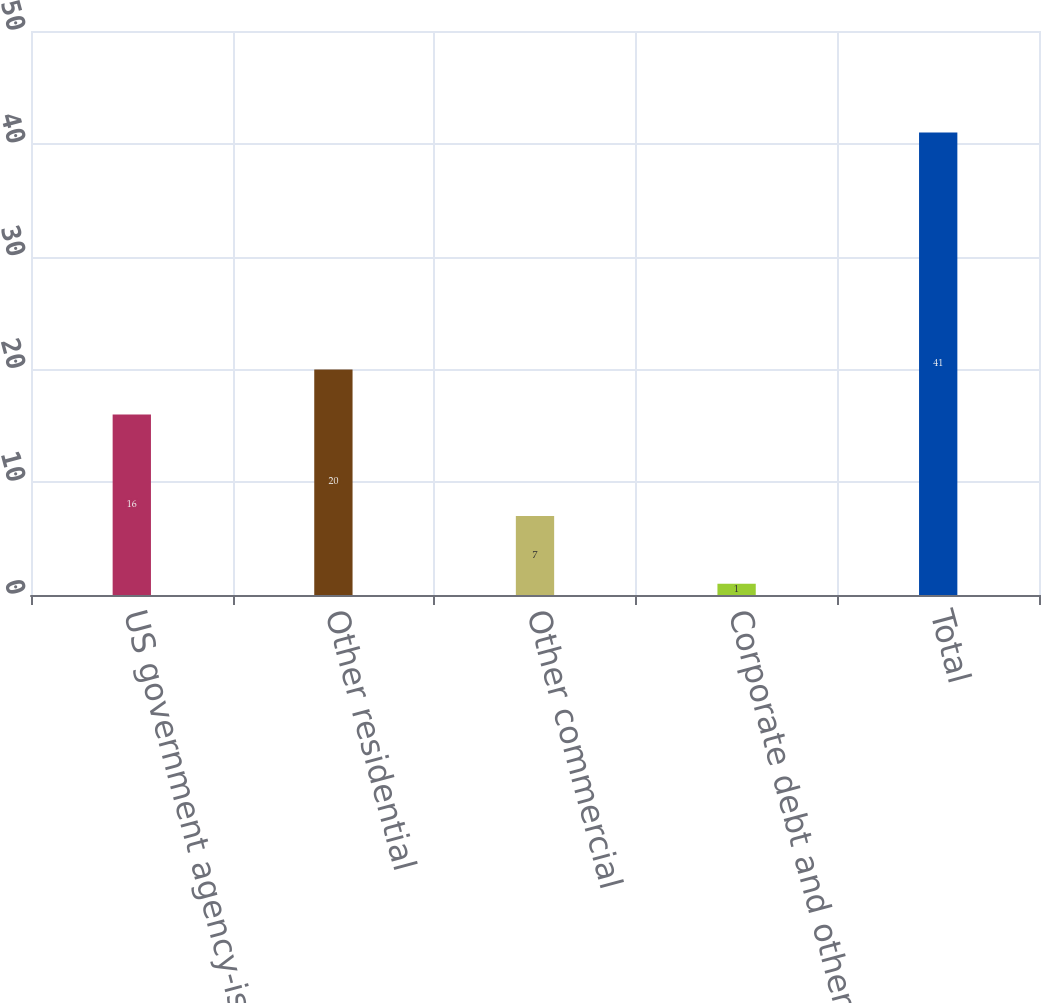<chart> <loc_0><loc_0><loc_500><loc_500><bar_chart><fcel>US government agency-issued<fcel>Other residential<fcel>Other commercial<fcel>Corporate debt and other<fcel>Total<nl><fcel>16<fcel>20<fcel>7<fcel>1<fcel>41<nl></chart> 